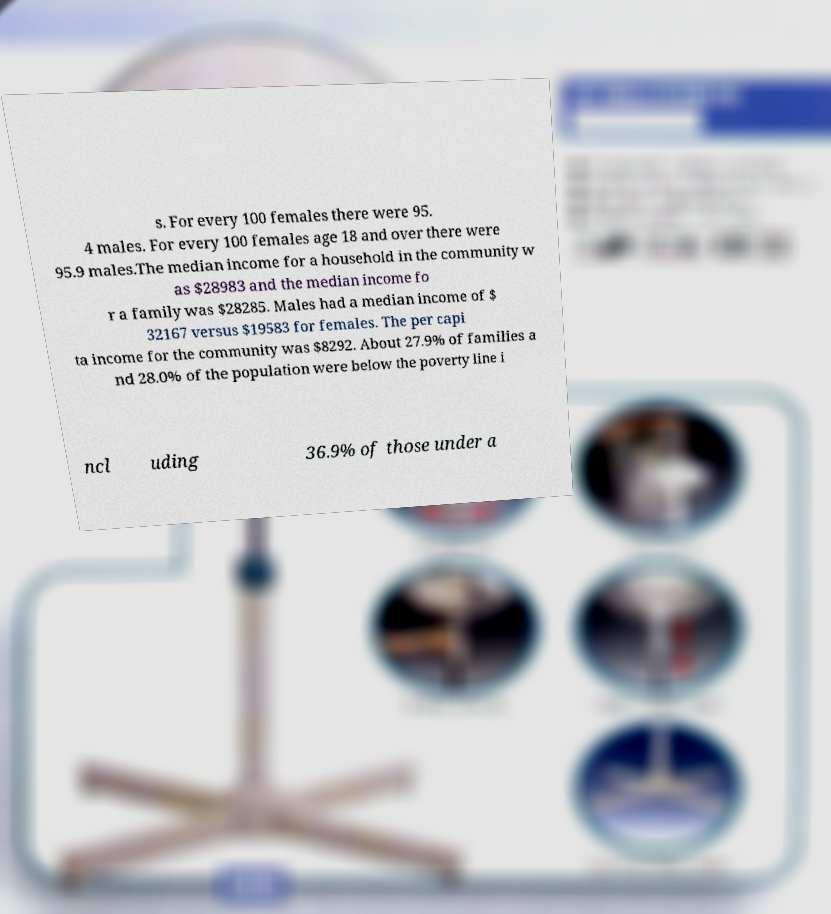Could you assist in decoding the text presented in this image and type it out clearly? s. For every 100 females there were 95. 4 males. For every 100 females age 18 and over there were 95.9 males.The median income for a household in the community w as $28983 and the median income fo r a family was $28285. Males had a median income of $ 32167 versus $19583 for females. The per capi ta income for the community was $8292. About 27.9% of families a nd 28.0% of the population were below the poverty line i ncl uding 36.9% of those under a 